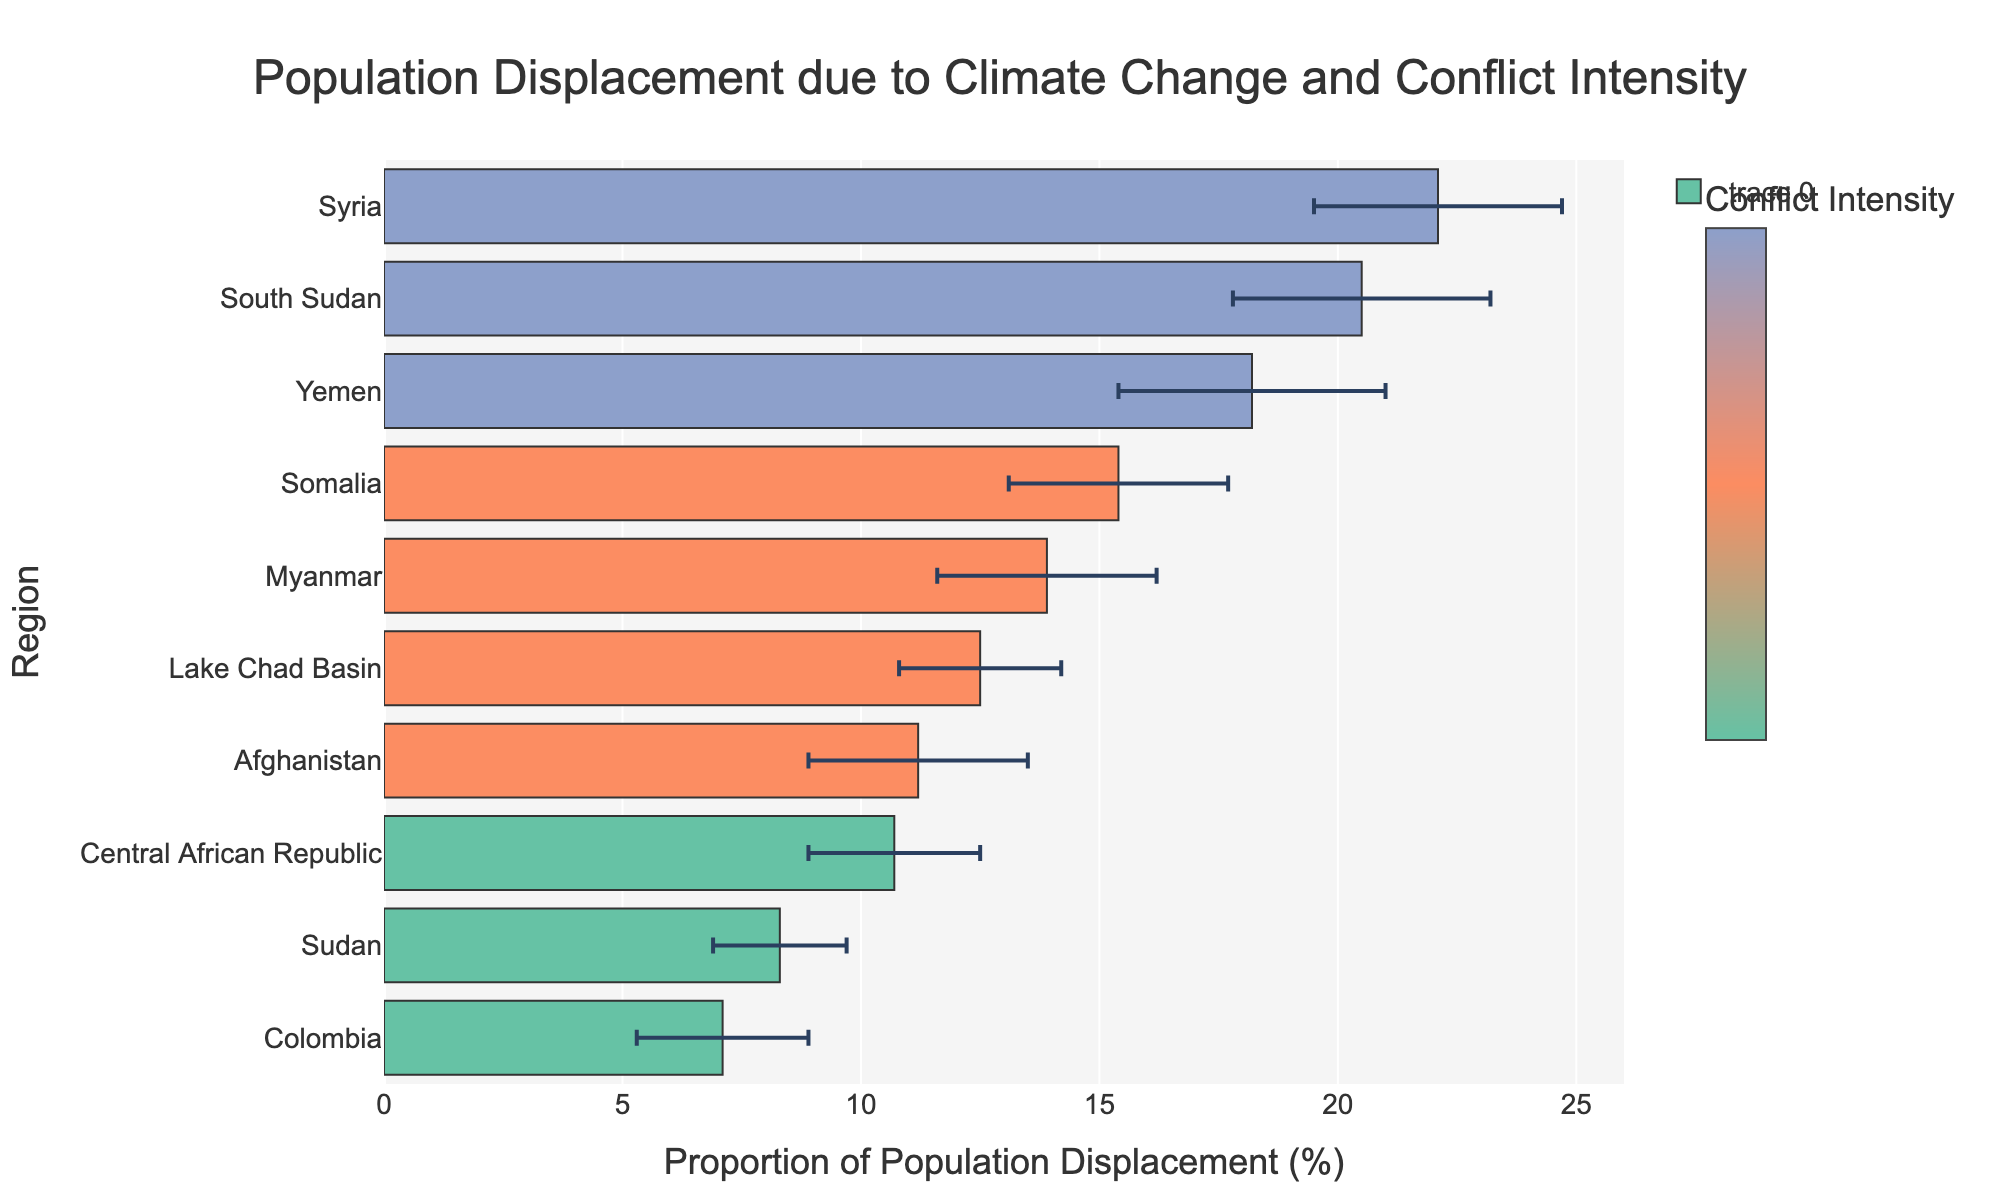What is the title of the figure? The title is located at the top of the figure, and it gives a summary of the chart's content.
Answer: Population Displacement due to Climate Change and Conflict Intensity Which region has the highest proportion of population displacement? To find the region with the highest proportion, look for the longest horizontal bar. In this figure, the longest bar represents Syria.
Answer: Syria What is the proportion of population displacement for Colombia? Identify the bar corresponding to Colombia and read the value on the x-axis.
Answer: 7.1% What is the average proportion of population displacement for regions with severe conflict intensity? Calculate the average by summing the proportions for Syria (22.1), Yemen (18.2), and South Sudan (20.5), and then divide by 3.
Answer: (22.1 + 18.2 + 20.5)/3 = 20.27% Which region has a higher proportion of displacement, Afghanistan or Myanmar? Compare the lengths of the bars for Afghanistan and Myanmar; Myanmar's bar is longer.
Answer: Myanmar What is the total error range for Somalia's displacement estimate? The error range is the sum of the differences between the upper and lower bounds (17.7 - 13.1).
Answer: 17.7 - 13.1 = 4.6 How does the color scheme of the bars relate to the intensity of conflict? Each color corresponds to an intensity level: moderate (green), high (orange), severe (blue). This is indicated in the color scale legend.
Answer: Colors indicate conflict intensity What is the range of population displacement estimates for Sudan? Sudan's lower and upper bounds are 6.9% and 9.7%, respectively. Subtract the lower bound from the upper bound.
Answer: 9.7% - 6.9% = 2.8% Which region has the smallest error margin in the displacement estimate? Compare the length of the error bars and find the region with the shortest error bars. In this figure, Colombia has the smallest error margin.
Answer: Colombia How many regions have a displacement estimate with a lower bound above 10%? Check each region's lower bound estimate; count those above 10%. Regions are Lake Chad Basin, Syria, Somalia, Yemen, Myanmar, and South Sudan.
Answer: 6 regions 